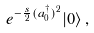Convert formula to latex. <formula><loc_0><loc_0><loc_500><loc_500>e ^ { - \frac { s } { 2 } ( a _ { 0 } ^ { \dagger } ) ^ { 2 } } | 0 \rangle \, ,</formula> 